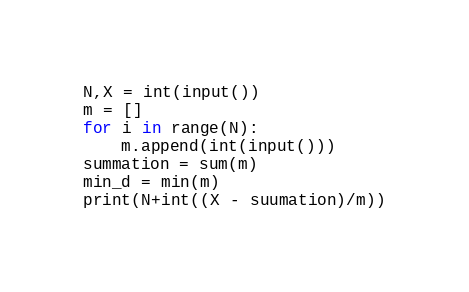Convert code to text. <code><loc_0><loc_0><loc_500><loc_500><_Python_>N,X = int(input())
m = []
for i in range(N):
    m.append(int(input()))
summation = sum(m)
min_d = min(m)
print(N+int((X - suumation)/m))
</code> 